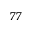<formula> <loc_0><loc_0><loc_500><loc_500>^ { 7 7 }</formula> 